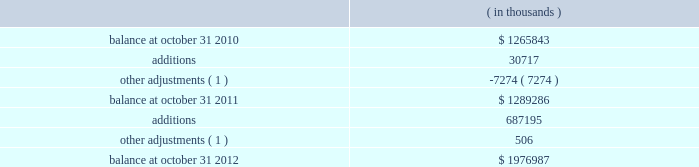Synopsys , inc .
Notes to consolidated financial statements 2014continued purchase price allocation .
The company allocated the total purchase consideration of $ 316.6 million ( including $ 4.6 million related to stock awards assumed ) to the assets acquired and liabilities assumed based on their respective fair values at the acquisition dates , including acquired identifiable intangible assets of $ 96.7 million and ipr&d of $ 13.2 million , resulting in total goodwill of $ 210.1 million .
Acquisition-related costs , consisting of professional services , severance costs , contract terminations and facilities closure costs , totaling $ 13.0 million were expensed as incurred in the consolidated statements of operations .
Goodwill primarily resulted from the company 2019s expectation of sales growth and cost synergies from the integration of virage 2019s technology with the company 2019s technology and operations to provide an expansion of products and market reach .
Identifiable intangible assets consisted of technology , customer relationships , contract rights and trademarks , were valued using the income method , and are being amortized over two to ten years .
Fair value of stock awards assumed .
The company assumed unvested restricted stock units ( rsus ) and stock appreciation rights ( sars ) with a fair value of $ 21.7 million .
Of the total consideration , $ 4.6 million was allocated to the purchase consideration and $ 17.1 million was allocated to future services and expensed over their remaining service periods on a straight-line basis .
Other fiscal 2010 acquisitions during fiscal 2010 , the company completed seven other acquisitions for cash .
The company allocated the total purchase consideration of $ 221.7 million to the assets acquired and liabilities assumed based on their respective fair values at the acquisition dates , resulting in total goodwill of $ 110.8 million .
Acquired identifiable intangible assets totaling $ 92.8 million are being amortized over their respective useful lives ranging from one to ten years .
Acquisition-related costs totaling $ 10.6 million were expensed as incurred in the consolidated statements of operations .
The purchase consideration for one of the acquisitions included contingent consideration up to $ 10.0 million payable upon the achievement of certain technology milestones over three years .
The contingent consideration was recorded as a liability at its estimated fair value determined based on the net present value of estimated payments of $ 7.8 million on the acquisition date and is being remeasured at fair value quarterly during the three-year contingency period with changes in its fair value recorded in the company 2019s statements of operations .
There is no contingent consideration liability as of the end of fiscal 2012 relating to this acquisition .
Note 4 .
Goodwill and intangible assets goodwill consists of the following: .
( 1 ) adjustments primarily relate to changes in estimates for acquisitions that closed in the prior fiscal year for which the purchase price allocation was still preliminary , and achievement of certain milestones for an acquisition that closed prior to fiscal 2010. .
What was the net change in thousands of the goodwill and intangible assets balance from october 31 , 2010 to october 31 , 2011? 
Computations: (1289286 - 1265843)
Answer: 23443.0. 